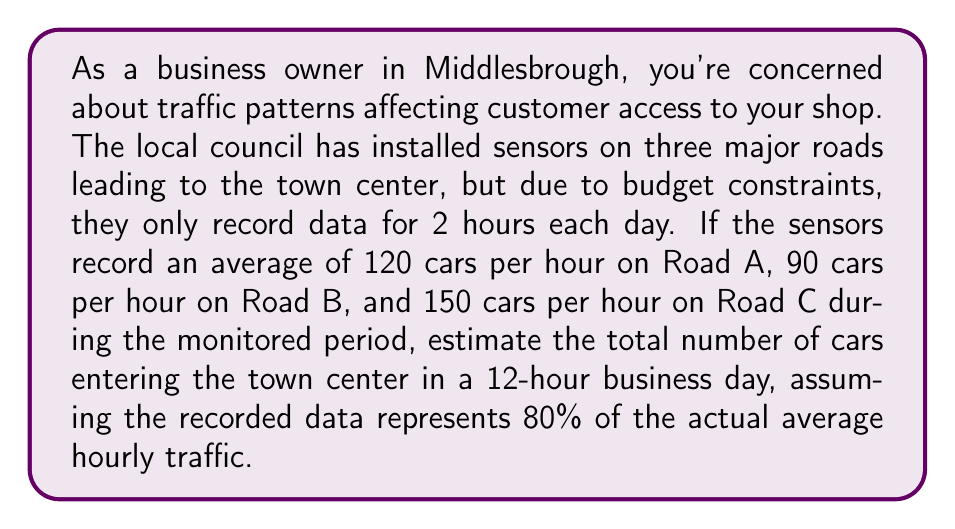Provide a solution to this math problem. Let's approach this step-by-step:

1) First, we need to calculate the total number of cars recorded during the 2-hour monitoring period:
   Road A: $120 \text{ cars/hour} \times 2 \text{ hours} = 240 \text{ cars}$
   Road B: $90 \text{ cars/hour} \times 2 \text{ hours} = 180 \text{ cars}$
   Road C: $150 \text{ cars/hour} \times 2 \text{ hours} = 300 \text{ cars}$

2) Total cars recorded in 2 hours: $240 + 180 + 300 = 720 \text{ cars}$

3) Now, we need to adjust for the fact that this represents only 80% of the actual traffic:
   Let $x$ be the actual number of cars in 2 hours.
   $720 = 0.8x$
   $x = 720 / 0.8 = 900 \text{ cars}$

4) So, the actual average number of cars per hour is:
   $900 \text{ cars} / 2 \text{ hours} = 450 \text{ cars/hour}$

5) For a 12-hour business day, the total number of cars would be:
   $450 \text{ cars/hour} \times 12 \text{ hours} = 5400 \text{ cars}$
Answer: 5400 cars 